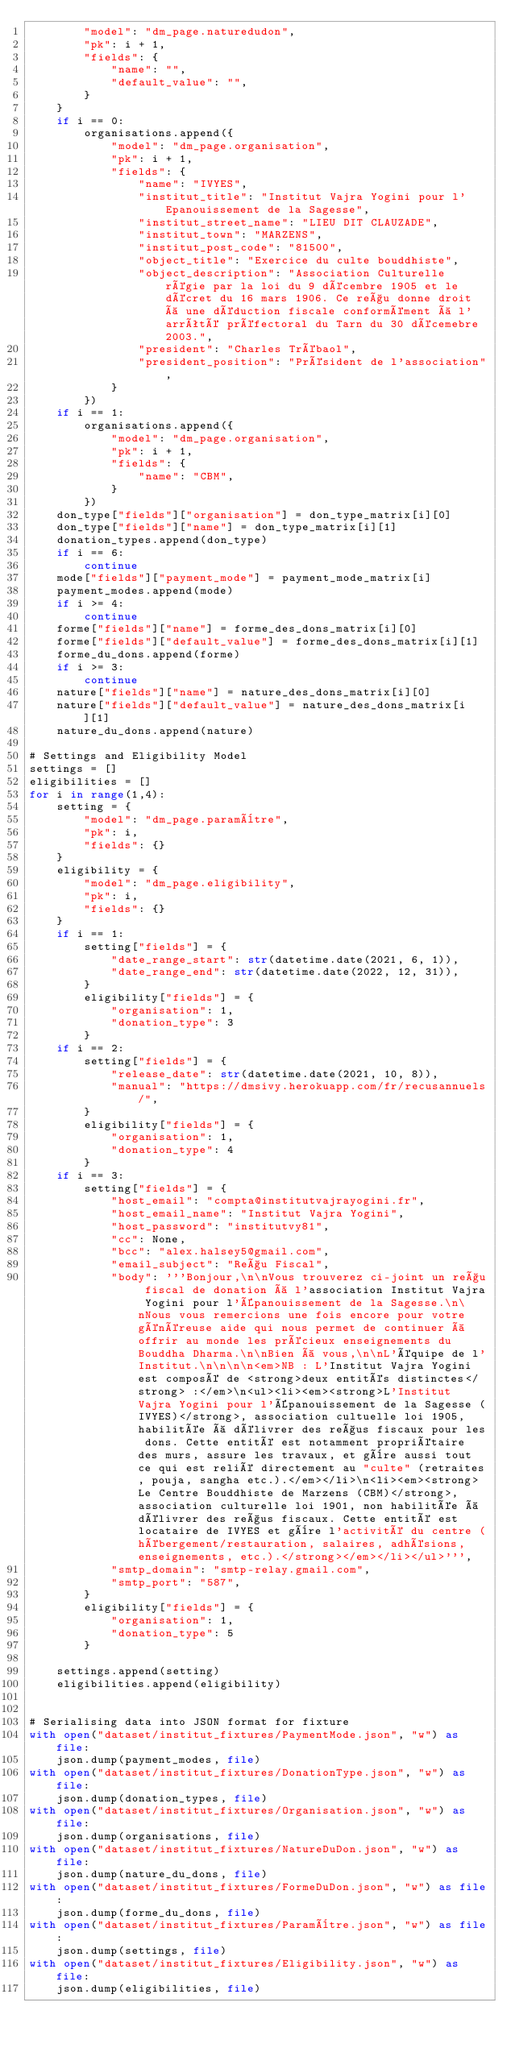Convert code to text. <code><loc_0><loc_0><loc_500><loc_500><_Python_>        "model": "dm_page.naturedudon",
        "pk": i + 1,
        "fields": {
            "name": "",
            "default_value": "",
        }
    }
    if i == 0:
        organisations.append({
            "model": "dm_page.organisation",
            "pk": i + 1,
            "fields": {
                "name": "IVYES",
                "institut_title": "Institut Vajra Yogini pour l'Epanouissement de la Sagesse",
                "institut_street_name": "LIEU DIT CLAUZADE",
                "institut_town": "MARZENS",
                "institut_post_code": "81500",
                "object_title": "Exercice du culte bouddhiste",
                "object_description": "Association Culturelle régie par la loi du 9 décembre 1905 et le décret du 16 mars 1906. Ce reçu donne droit à une déduction fiscale conformément à l'arrêté préfectoral du Tarn du 30 décemebre 2003.",
                "president": "Charles Trébaol",
                "president_position": "Président de l'association",
            }
        })
    if i == 1:
        organisations.append({
            "model": "dm_page.organisation",
            "pk": i + 1,
            "fields": {
                "name": "CBM",
            }
        })
    don_type["fields"]["organisation"] = don_type_matrix[i][0]
    don_type["fields"]["name"] = don_type_matrix[i][1]
    donation_types.append(don_type)
    if i == 6:
        continue
    mode["fields"]["payment_mode"] = payment_mode_matrix[i]
    payment_modes.append(mode)
    if i >= 4:
        continue
    forme["fields"]["name"] = forme_des_dons_matrix[i][0]
    forme["fields"]["default_value"] = forme_des_dons_matrix[i][1]
    forme_du_dons.append(forme)
    if i >= 3:
        continue
    nature["fields"]["name"] = nature_des_dons_matrix[i][0]
    nature["fields"]["default_value"] = nature_des_dons_matrix[i][1]  
    nature_du_dons.append(nature)

# Settings and Eligibility Model
settings = []
eligibilities = []
for i in range(1,4):
    setting = {
        "model": "dm_page.paramètre",
        "pk": i,
        "fields": {}
    }
    eligibility = {
        "model": "dm_page.eligibility",
        "pk": i,
        "fields": {}
    }
    if i == 1:
        setting["fields"] = {
            "date_range_start": str(datetime.date(2021, 6, 1)),
            "date_range_end": str(datetime.date(2022, 12, 31)),
        }
        eligibility["fields"] = {
            "organisation": 1,
            "donation_type": 3
        }
    if i == 2:
        setting["fields"] = {
            "release_date": str(datetime.date(2021, 10, 8)),
            "manual": "https://dmsivy.herokuapp.com/fr/recusannuels/",
        }
        eligibility["fields"] = {
            "organisation": 1,
            "donation_type": 4
        }
    if i == 3:
        setting["fields"] = {
            "host_email": "compta@institutvajrayogini.fr",
            "host_email_name": "Institut Vajra Yogini",
            "host_password": "institutvy81",
            "cc": None,
            "bcc": "alex.halsey5@gmail.com",
            "email_subject": "Reçu Fiscal",
            "body": '''Bonjour,\n\nVous trouverez ci-joint un reçu fiscal de donation à l'association Institut Vajra Yogini pour l'Épanouissement de la Sagesse.\n\nNous vous remercions une fois encore pour votre généreuse aide qui nous permet de continuer à offrir au monde les précieux enseignements du Bouddha Dharma.\n\nBien à vous,\n\nL'équipe de l'Institut.\n\n\n\n<em>NB : L'Institut Vajra Yogini est composé de <strong>deux entités distinctes</strong> :</em>\n<ul><li><em><strong>L'Institut Vajra Yogini pour l'Épanouissement de la Sagesse (IVYES)</strong>, association cultuelle loi 1905, habilitée à délivrer des reçus fiscaux pour les dons. Cette entité est notamment propriétaire des murs, assure les travaux, et gère aussi tout ce qui est relié directement au "culte" (retraites, pouja, sangha etc.).</em></li>\n<li><em><strong>Le Centre Bouddhiste de Marzens (CBM)</strong>, association culturelle loi 1901, non habilitée à délivrer des reçus fiscaux. Cette entité est locataire de IVYES et gère l'activité du centre (hébergement/restauration, salaires, adhésions, enseignements, etc.).</strong></em></li></ul>''',
            "smtp_domain": "smtp-relay.gmail.com",
            "smtp_port": "587", 
        }
        eligibility["fields"] = {
            "organisation": 1,
            "donation_type": 5
        }
    
    settings.append(setting)
    eligibilities.append(eligibility)


# Serialising data into JSON format for fixture 
with open("dataset/institut_fixtures/PaymentMode.json", "w") as file:
    json.dump(payment_modes, file)
with open("dataset/institut_fixtures/DonationType.json", "w") as file:
    json.dump(donation_types, file)
with open("dataset/institut_fixtures/Organisation.json", "w") as file:
    json.dump(organisations, file)
with open("dataset/institut_fixtures/NatureDuDon.json", "w") as file:
    json.dump(nature_du_dons, file)
with open("dataset/institut_fixtures/FormeDuDon.json", "w") as file:
    json.dump(forme_du_dons, file)
with open("dataset/institut_fixtures/Paramètre.json", "w") as file:
    json.dump(settings, file)
with open("dataset/institut_fixtures/Eligibility.json", "w") as file:
    json.dump(eligibilities, file)</code> 